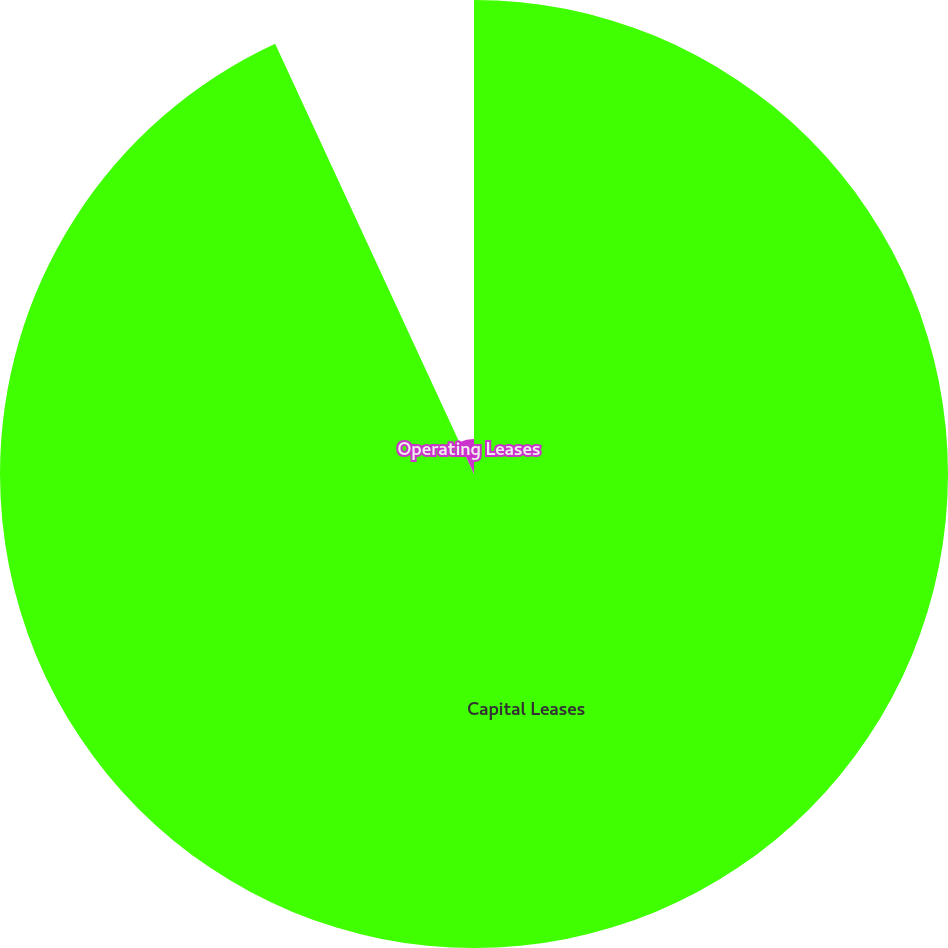Convert chart to OTSL. <chart><loc_0><loc_0><loc_500><loc_500><pie_chart><fcel>Capital Leases<fcel>Operating Leases<nl><fcel>93.11%<fcel>6.89%<nl></chart> 